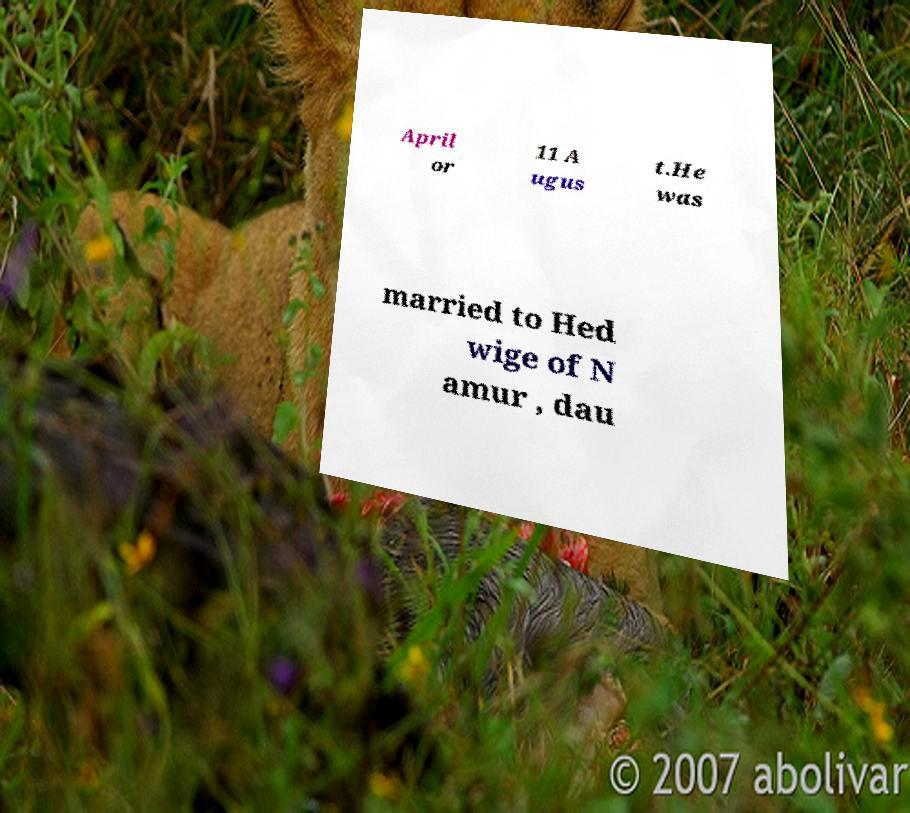Could you extract and type out the text from this image? April or 11 A ugus t.He was married to Hed wige of N amur , dau 